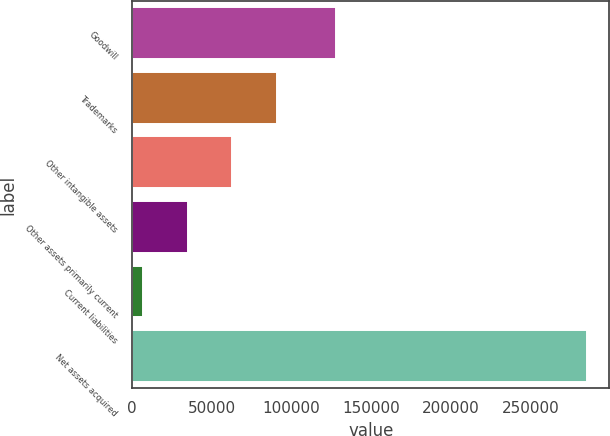<chart> <loc_0><loc_0><loc_500><loc_500><bar_chart><fcel>Goodwill<fcel>Trademarks<fcel>Other intangible assets<fcel>Other assets primarily current<fcel>Current liabilities<fcel>Net assets acquired<nl><fcel>128110<fcel>91200<fcel>62843.6<fcel>35027.3<fcel>7211<fcel>285374<nl></chart> 